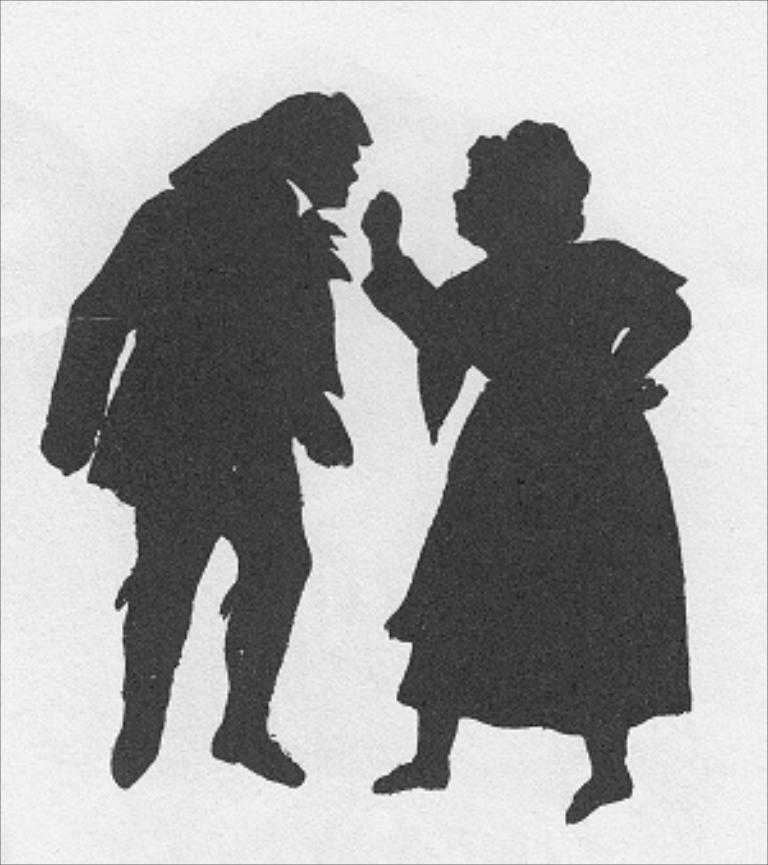What is depicted in the picture? There is a picture of a man and a woman in the image. What color scheme is used in the picture? The picture is in black and white. Can you describe the background of the picture? The background of the picture is blurred. How many umbrellas are visible in the picture? There are no umbrellas present in the picture; it features a picture of a man and a woman in a black and white setting with a blurred background. 